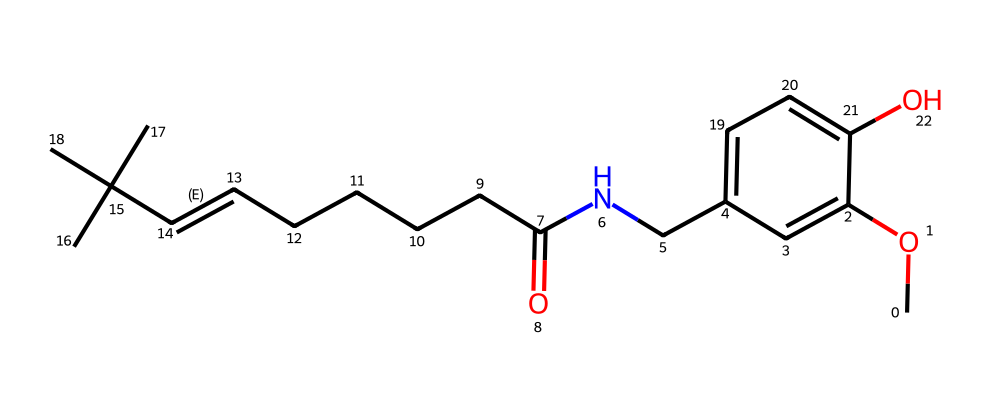What is the name of this chemical? The provided SMILES representation corresponds to capsaicin, which is known for giving chili peppers their characteristic spiciness.
Answer: capsaicin How many carbon atoms are present in the structure? Analyzing the SMILES string, we can count the number of carbon atoms represented. Capsaicin has a total of 18 carbon atoms.
Answer: 18 What functional groups can be identified in this compound? The SMILES representation indicates the presence of an ether group (CO) and an amide group (CNC(=O)), which are key functional groups in the capsaicin structure.
Answer: ether and amide What bonds are predominantly found in this molecule? The chemical structure features single and double bonds, with multiple carbon-carbon single bonds and one carbon-carbon double bond (C=C) within the aliphatic chain.
Answer: single and double Is this molecule saturated or unsaturated? The presence of a carbon-carbon double bond (C=C) indicates that capsaicin is unsaturated, as unsaturation refers to the presence of double or triple bonds in organic molecules.
Answer: unsaturated What type of lipid is capsaicin classified as? Capsaicin is classified as a non-ester lipid, specifically because it does not possess the ester bonds typically found in many lipids.
Answer: non-ester lipid Which part of the molecule is responsible for its spiciness? The vanillyl ring and the long aliphatic chain contribute to the characteristic spiciness of capsaicin, as this arrangement is associated with its interaction with the receptors that perceive heat and pain.
Answer: vanillyl ring and aliphatic chain 